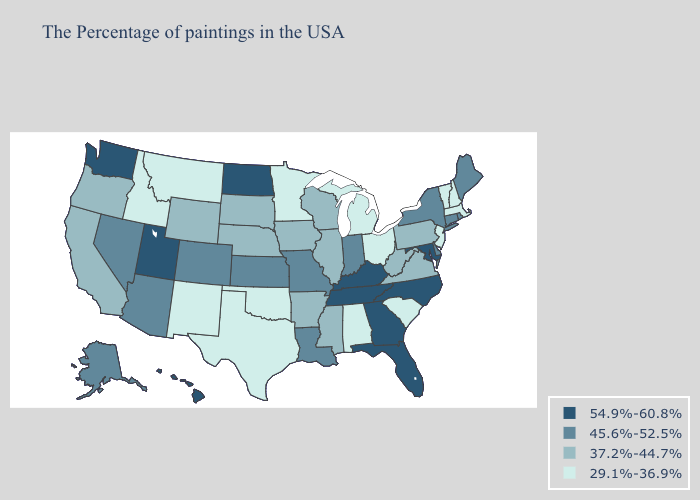Does Washington have a higher value than Maryland?
Write a very short answer. No. Name the states that have a value in the range 54.9%-60.8%?
Short answer required. Maryland, North Carolina, Florida, Georgia, Kentucky, Tennessee, North Dakota, Utah, Washington, Hawaii. Does New York have the highest value in the USA?
Write a very short answer. No. Which states have the lowest value in the MidWest?
Answer briefly. Ohio, Michigan, Minnesota. Which states have the lowest value in the USA?
Write a very short answer. Massachusetts, New Hampshire, Vermont, New Jersey, South Carolina, Ohio, Michigan, Alabama, Minnesota, Oklahoma, Texas, New Mexico, Montana, Idaho. Does Kansas have a higher value than Montana?
Keep it brief. Yes. Does Maine have the highest value in the Northeast?
Short answer required. Yes. Name the states that have a value in the range 54.9%-60.8%?
Give a very brief answer. Maryland, North Carolina, Florida, Georgia, Kentucky, Tennessee, North Dakota, Utah, Washington, Hawaii. Among the states that border North Carolina , which have the lowest value?
Be succinct. South Carolina. What is the value of Alabama?
Keep it brief. 29.1%-36.9%. Does Texas have the same value as Kansas?
Answer briefly. No. What is the highest value in the West ?
Short answer required. 54.9%-60.8%. Does North Dakota have the highest value in the MidWest?
Concise answer only. Yes. What is the value of Louisiana?
Write a very short answer. 45.6%-52.5%. Which states have the lowest value in the MidWest?
Write a very short answer. Ohio, Michigan, Minnesota. 